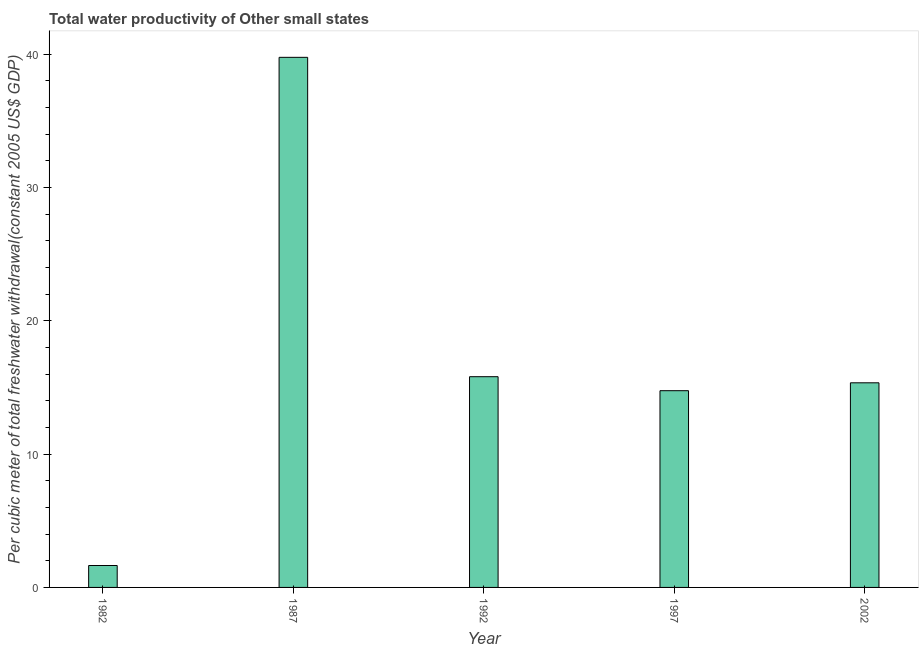Does the graph contain grids?
Make the answer very short. No. What is the title of the graph?
Offer a very short reply. Total water productivity of Other small states. What is the label or title of the Y-axis?
Offer a very short reply. Per cubic meter of total freshwater withdrawal(constant 2005 US$ GDP). What is the total water productivity in 1982?
Keep it short and to the point. 1.64. Across all years, what is the maximum total water productivity?
Ensure brevity in your answer.  39.76. Across all years, what is the minimum total water productivity?
Give a very brief answer. 1.64. In which year was the total water productivity maximum?
Offer a terse response. 1987. What is the sum of the total water productivity?
Keep it short and to the point. 87.32. What is the difference between the total water productivity in 1987 and 1992?
Make the answer very short. 23.95. What is the average total water productivity per year?
Offer a terse response. 17.46. What is the median total water productivity?
Your response must be concise. 15.35. Do a majority of the years between 1992 and 1997 (inclusive) have total water productivity greater than 12 US$?
Your response must be concise. Yes. What is the ratio of the total water productivity in 1987 to that in 1997?
Make the answer very short. 2.69. What is the difference between the highest and the second highest total water productivity?
Your answer should be very brief. 23.95. Is the sum of the total water productivity in 1987 and 1997 greater than the maximum total water productivity across all years?
Keep it short and to the point. Yes. What is the difference between the highest and the lowest total water productivity?
Provide a short and direct response. 38.12. In how many years, is the total water productivity greater than the average total water productivity taken over all years?
Offer a terse response. 1. What is the Per cubic meter of total freshwater withdrawal(constant 2005 US$ GDP) of 1982?
Keep it short and to the point. 1.64. What is the Per cubic meter of total freshwater withdrawal(constant 2005 US$ GDP) in 1987?
Provide a short and direct response. 39.76. What is the Per cubic meter of total freshwater withdrawal(constant 2005 US$ GDP) in 1992?
Make the answer very short. 15.81. What is the Per cubic meter of total freshwater withdrawal(constant 2005 US$ GDP) of 1997?
Provide a succinct answer. 14.76. What is the Per cubic meter of total freshwater withdrawal(constant 2005 US$ GDP) of 2002?
Ensure brevity in your answer.  15.35. What is the difference between the Per cubic meter of total freshwater withdrawal(constant 2005 US$ GDP) in 1982 and 1987?
Offer a terse response. -38.12. What is the difference between the Per cubic meter of total freshwater withdrawal(constant 2005 US$ GDP) in 1982 and 1992?
Your response must be concise. -14.16. What is the difference between the Per cubic meter of total freshwater withdrawal(constant 2005 US$ GDP) in 1982 and 1997?
Provide a short and direct response. -13.11. What is the difference between the Per cubic meter of total freshwater withdrawal(constant 2005 US$ GDP) in 1982 and 2002?
Provide a succinct answer. -13.7. What is the difference between the Per cubic meter of total freshwater withdrawal(constant 2005 US$ GDP) in 1987 and 1992?
Your answer should be compact. 23.96. What is the difference between the Per cubic meter of total freshwater withdrawal(constant 2005 US$ GDP) in 1987 and 1997?
Offer a very short reply. 25.01. What is the difference between the Per cubic meter of total freshwater withdrawal(constant 2005 US$ GDP) in 1987 and 2002?
Your answer should be very brief. 24.41. What is the difference between the Per cubic meter of total freshwater withdrawal(constant 2005 US$ GDP) in 1992 and 1997?
Offer a terse response. 1.05. What is the difference between the Per cubic meter of total freshwater withdrawal(constant 2005 US$ GDP) in 1992 and 2002?
Give a very brief answer. 0.46. What is the difference between the Per cubic meter of total freshwater withdrawal(constant 2005 US$ GDP) in 1997 and 2002?
Offer a terse response. -0.59. What is the ratio of the Per cubic meter of total freshwater withdrawal(constant 2005 US$ GDP) in 1982 to that in 1987?
Offer a very short reply. 0.04. What is the ratio of the Per cubic meter of total freshwater withdrawal(constant 2005 US$ GDP) in 1982 to that in 1992?
Provide a succinct answer. 0.1. What is the ratio of the Per cubic meter of total freshwater withdrawal(constant 2005 US$ GDP) in 1982 to that in 1997?
Offer a terse response. 0.11. What is the ratio of the Per cubic meter of total freshwater withdrawal(constant 2005 US$ GDP) in 1982 to that in 2002?
Make the answer very short. 0.11. What is the ratio of the Per cubic meter of total freshwater withdrawal(constant 2005 US$ GDP) in 1987 to that in 1992?
Offer a terse response. 2.52. What is the ratio of the Per cubic meter of total freshwater withdrawal(constant 2005 US$ GDP) in 1987 to that in 1997?
Offer a very short reply. 2.69. What is the ratio of the Per cubic meter of total freshwater withdrawal(constant 2005 US$ GDP) in 1987 to that in 2002?
Offer a terse response. 2.59. What is the ratio of the Per cubic meter of total freshwater withdrawal(constant 2005 US$ GDP) in 1992 to that in 1997?
Provide a succinct answer. 1.07. What is the ratio of the Per cubic meter of total freshwater withdrawal(constant 2005 US$ GDP) in 1992 to that in 2002?
Offer a terse response. 1.03. What is the ratio of the Per cubic meter of total freshwater withdrawal(constant 2005 US$ GDP) in 1997 to that in 2002?
Offer a very short reply. 0.96. 